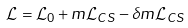Convert formula to latex. <formula><loc_0><loc_0><loc_500><loc_500>\mathcal { L } = \mathcal { L } _ { 0 } + m \mathcal { L } _ { C S } - \delta m \mathcal { L } _ { C S }</formula> 